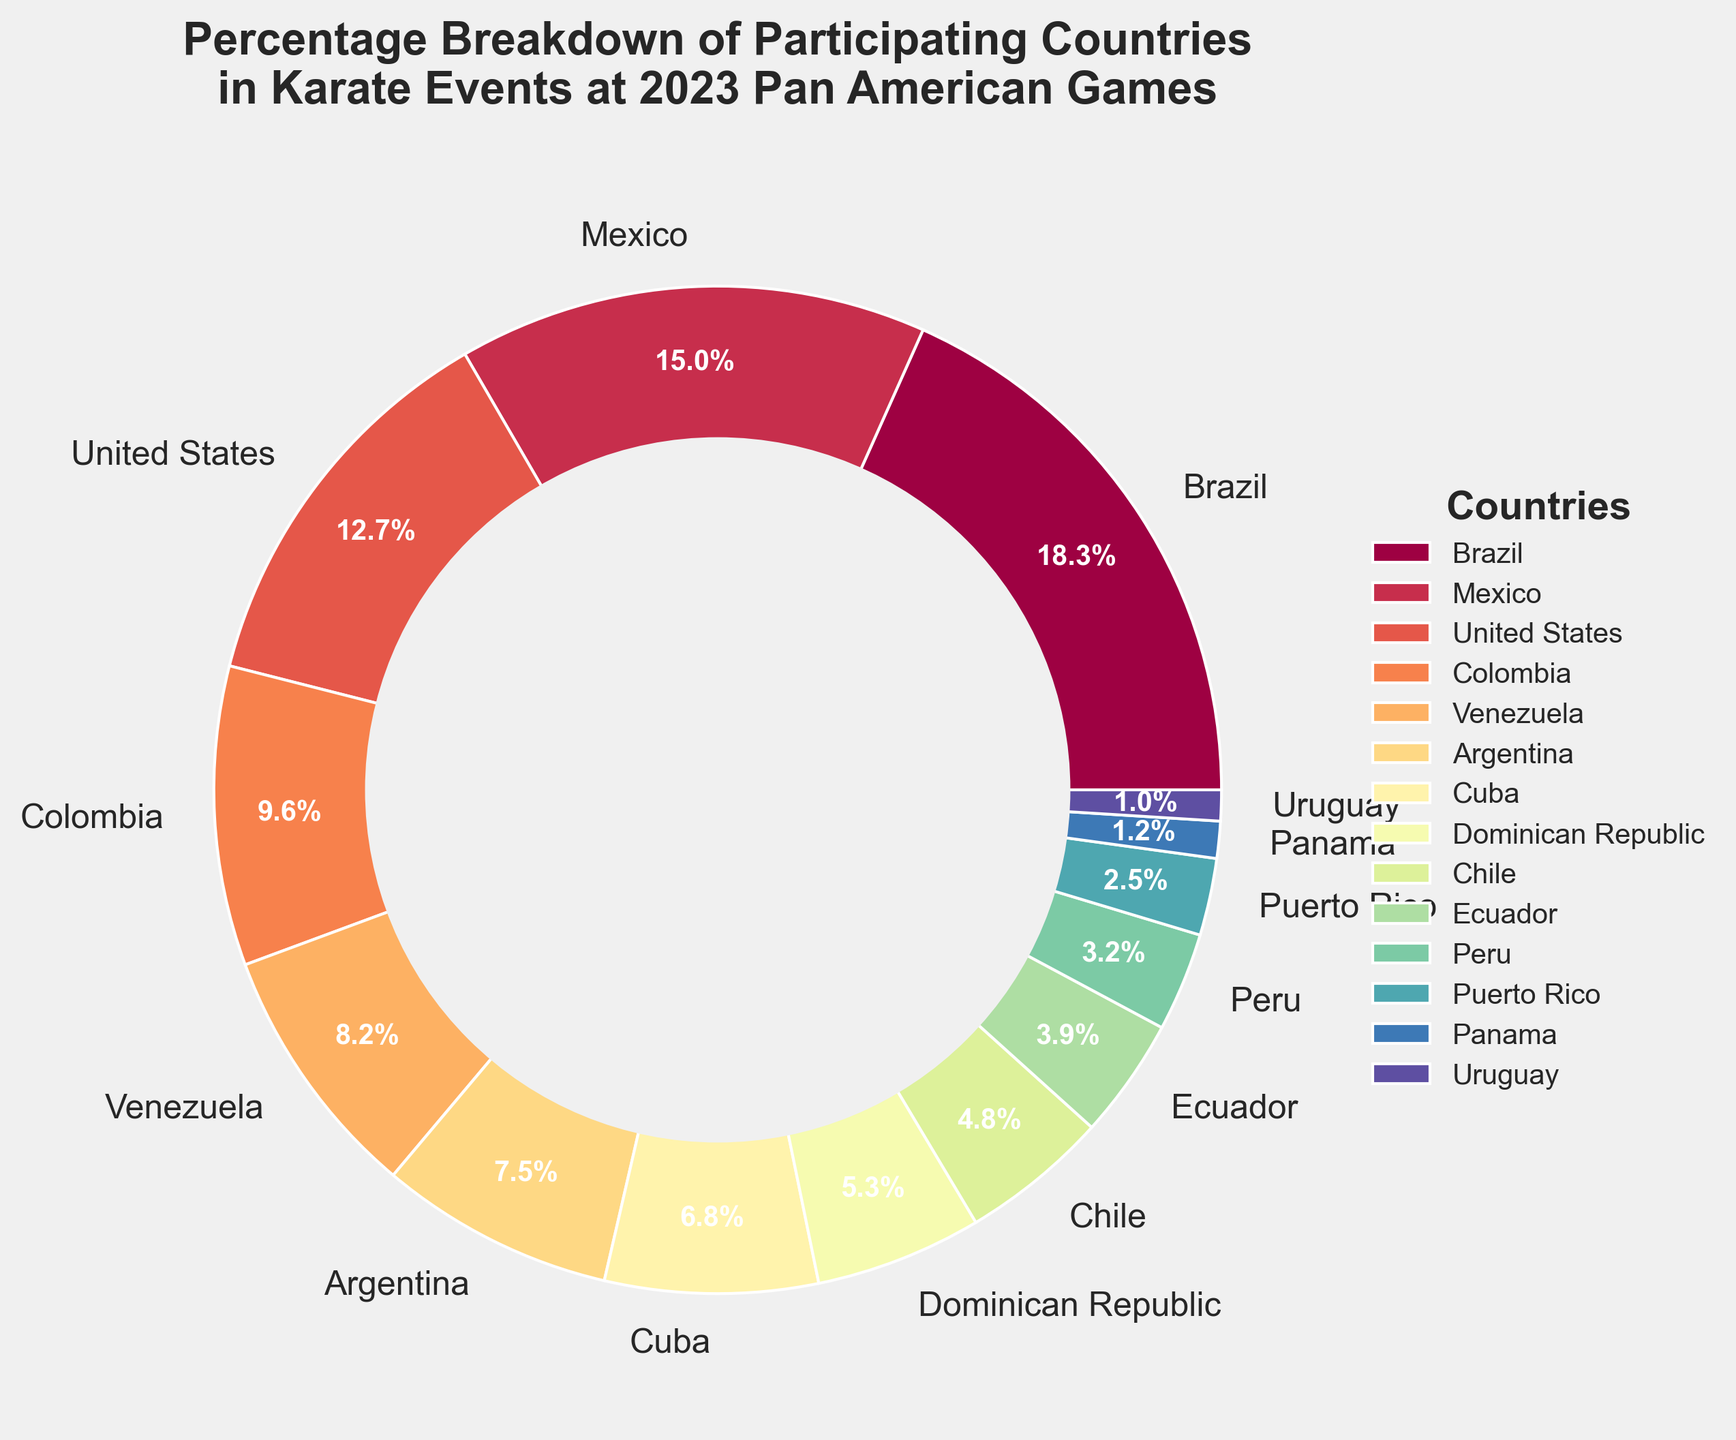What country has the highest percentage of participation in karate events? The pie chart shows different countries with Brazil having the largest wedge, indicating the highest percentage.
Answer: Brazil Which country has a higher participation percentage: Mexico or the United States? By comparing the percentages on the pie chart, Mexico has 15.2% while the United States has 12.8%.
Answer: Mexico What is the combined participation percentage of Colombia and Venezuela? Sum the percentages of Colombia and Venezuela (9.7% and 8.3%) to get the total. 9.7% + 8.3% = 18.0%
Answer: 18.0% Which country contributes the least to the karate events? Look for the smallest wedge on the pie chart, which represents the least contribution by Uruguay at 1.0%.
Answer: Uruguay Compare the combined percentage of Argentina and Cuba with the percentage of Brazil. Which is higher? Sum the percentages of Argentina and Cuba (7.6% + 6.9% = 14.5%) and compare it with Brazil's 18.5%. Brazil's percentage is higher.
Answer: Brazil What is the percentage difference between Peru and Puerto Rico? Subtract Peru's percentage from Puerto Rico's percentage (3.2% - 2.5% = 0.7%).
Answer: 0.7% How does the participation of Chile compare to that of Ecuador? Comparing their percentages, Chile has 4.8% and Ecuador has 3.9%. Chile has a higher percentage.
Answer: Chile Which countries have a participation percentage below 5%? Observing the chart, the countries with a participation percentage below 5% are Chile (4.8%), Ecuador (3.9%), Peru (3.2%), Puerto Rico (2.5%), Panama (1.2%), and Uruguay (1.0%).
Answer: Chile, Ecuador, Peru, Puerto Rico, Panama, Uruguay Is the percentage of Mexico more than double that of Dominican Republic? Comparing Mexico's 15.2% with twice the Dominican Republic's 5.4% (which is 10.8%), Mexico's percentage is greater.
Answer: Yes What is the average participation percentage of the top three countries? Calculate the mean of the percentages for Brazil (18.5%), Mexico (15.2%), and the United States (12.8%) by adding them and dividing by 3. (18.5 + 15.2 + 12.8) / 3 = 15.5%
Answer: 15.5% 